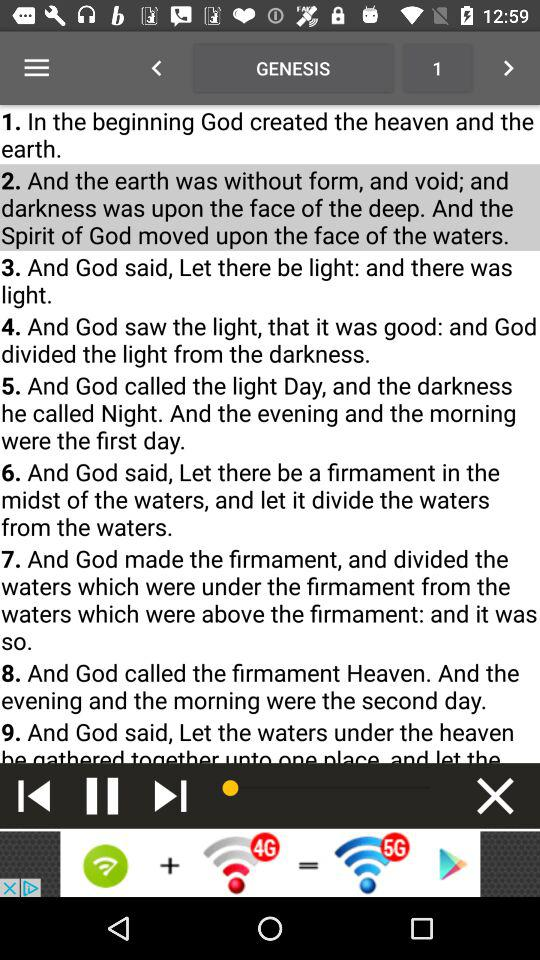Who is the author of "GENESIS"?
When the provided information is insufficient, respond with <no answer>. <no answer> 